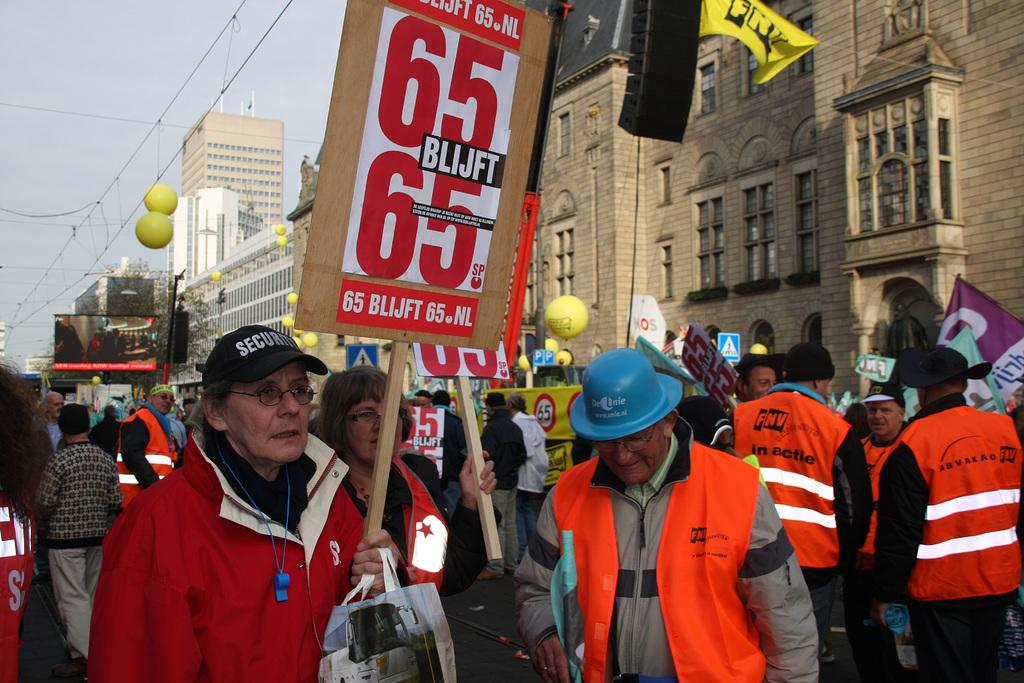What are the persons on the road doing? The persons on the road are holding placards. What can be seen on the display screen? The facts do not mention the content of the display screen. What type of infrastructure is present in the image? Electric cables, buildings, windows, grills, and trees are present in the image. What additional objects are visible in the image? Balloons are visible in the image. What is visible in the sky? The sky is visible in the image. What type of disease is being protested against in the image? There is no indication of a protest or a specific disease in the image. What type of fan is visible in the image? There is no fan present in the image. 